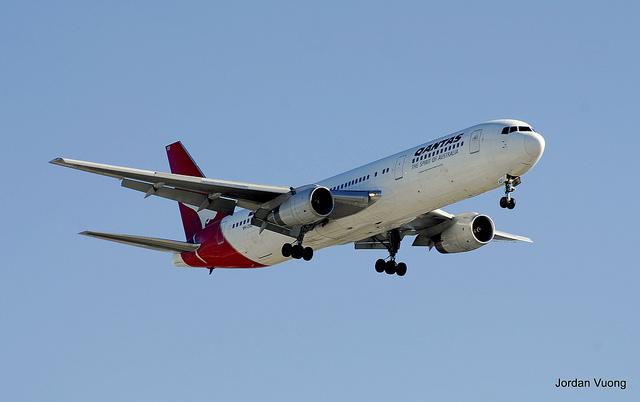Is this a cargo plane?
Short answer required. No. What airline is this?
Write a very short answer. Qantas. What airline is the plane from?
Answer briefly. Qantas. Is there a flag on the plane?
Give a very brief answer. No. Can this plane hold more than 20 passengers?
Give a very brief answer. Yes. How many wheels can be seen on the plane?
Keep it brief. 8. 